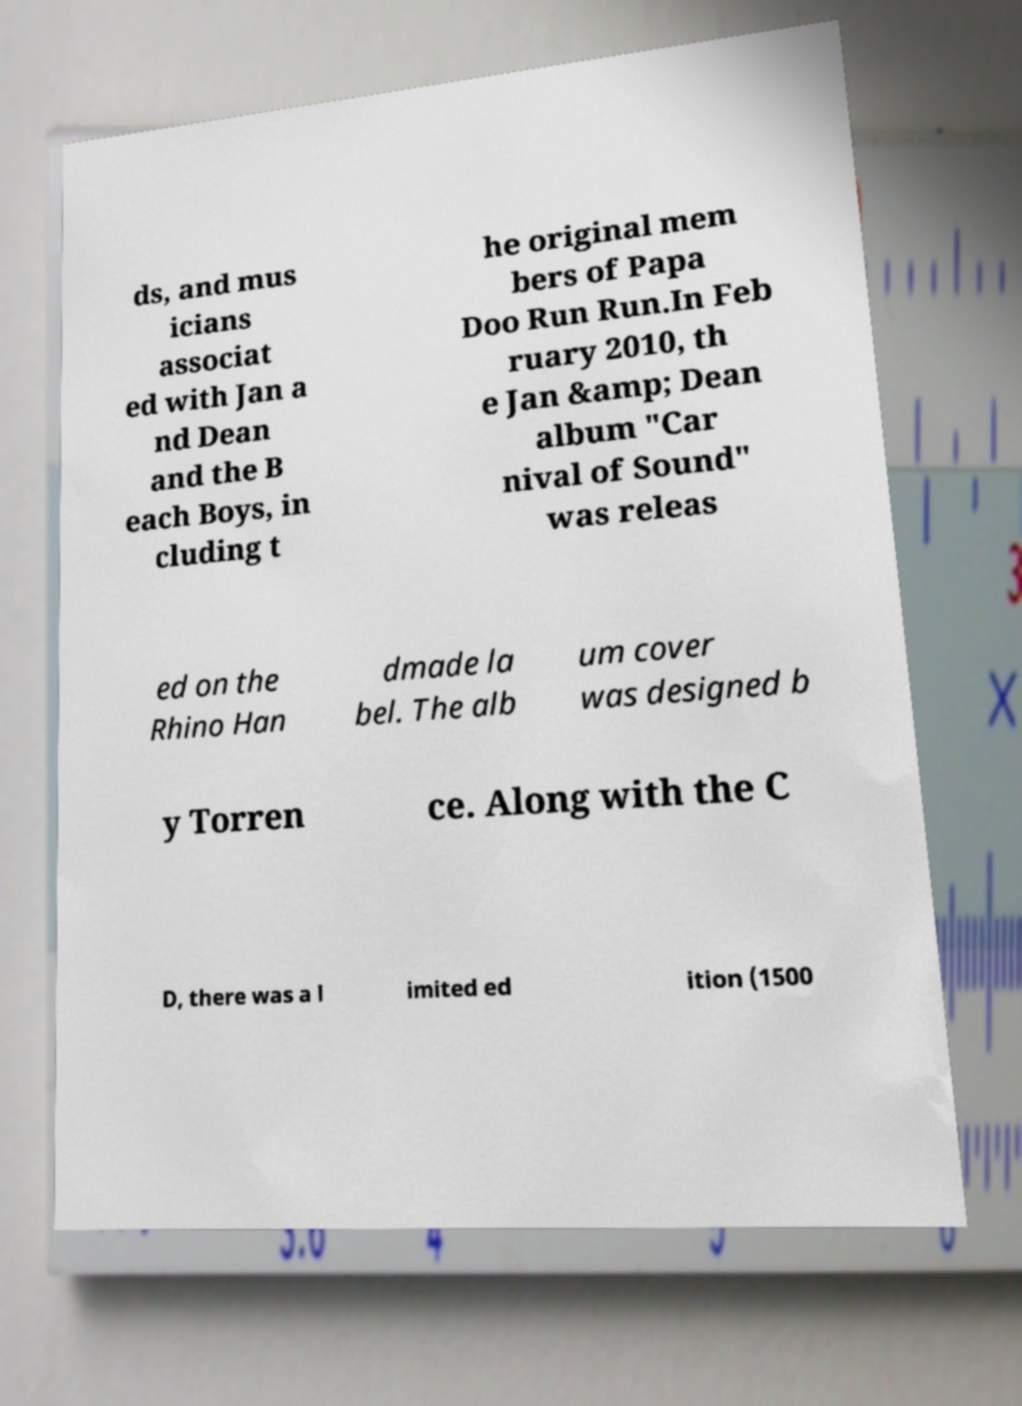I need the written content from this picture converted into text. Can you do that? ds, and mus icians associat ed with Jan a nd Dean and the B each Boys, in cluding t he original mem bers of Papa Doo Run Run.In Feb ruary 2010, th e Jan &amp; Dean album "Car nival of Sound" was releas ed on the Rhino Han dmade la bel. The alb um cover was designed b y Torren ce. Along with the C D, there was a l imited ed ition (1500 